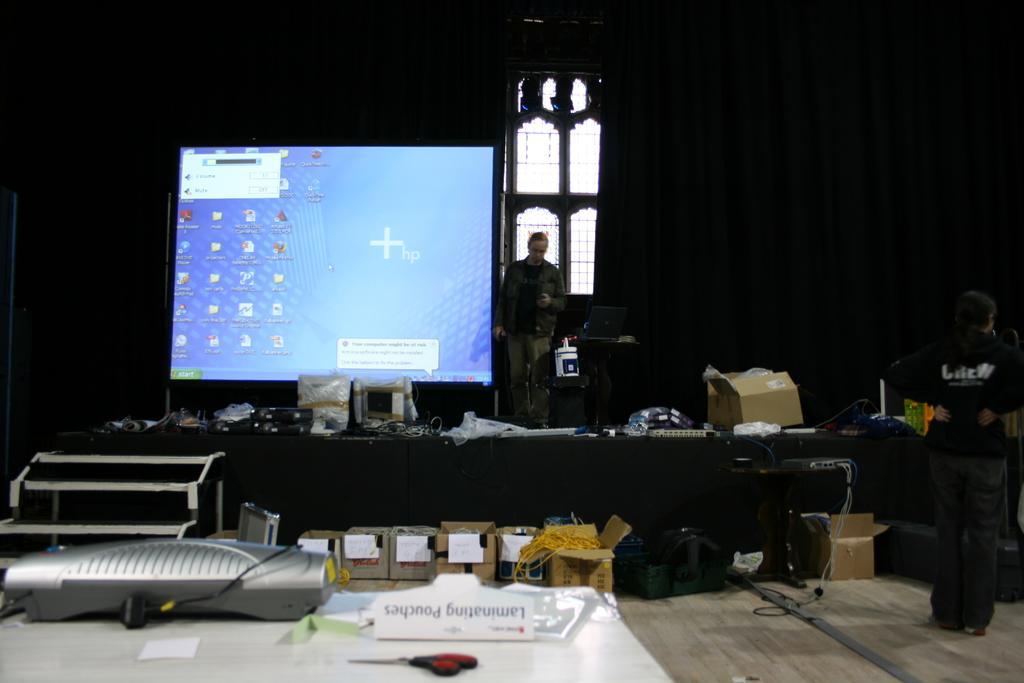Describe this image in one or two sentences. There is a scissor, a paper, an object and a card on the white color table. In the background, there are books arranged on the floor. There is a person standing on a stage on which, there is a screen arranged and other objects. And the background is dark in color. 